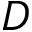Convert formula to latex. <formula><loc_0><loc_0><loc_500><loc_500>D</formula> 